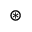<formula> <loc_0><loc_0><loc_500><loc_500>\circledast</formula> 